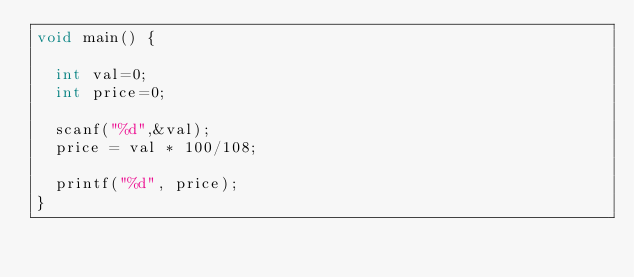Convert code to text. <code><loc_0><loc_0><loc_500><loc_500><_C_>void main() {
  
  int val=0;
  int price=0;
  
  scanf("%d",&val);
  price = val * 100/108;
  
  printf("%d", price);
}</code> 